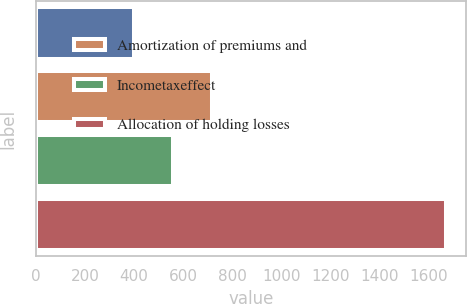Convert chart to OTSL. <chart><loc_0><loc_0><loc_500><loc_500><bar_chart><ecel><fcel>Amortization of premiums and<fcel>Incometaxeffect<fcel>Allocation of holding losses<nl><fcel>398.8<fcel>716.6<fcel>557.7<fcel>1670<nl></chart> 